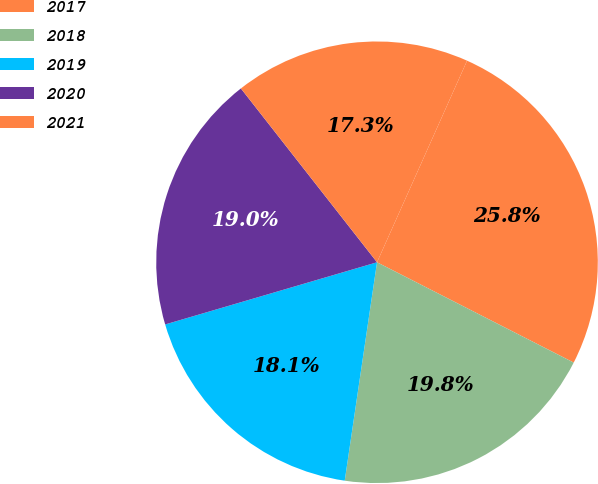<chart> <loc_0><loc_0><loc_500><loc_500><pie_chart><fcel>2017<fcel>2018<fcel>2019<fcel>2020<fcel>2021<nl><fcel>25.82%<fcel>19.83%<fcel>18.12%<fcel>18.97%<fcel>17.26%<nl></chart> 